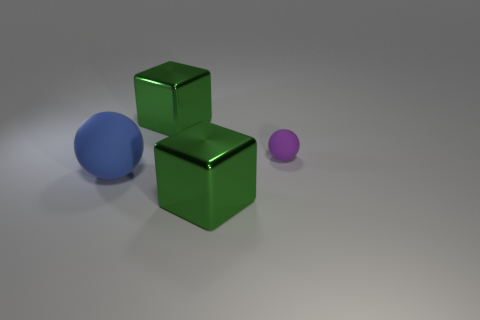Are there any other things that are the same size as the purple rubber sphere?
Keep it short and to the point. No. The rubber object that is behind the rubber ball in front of the purple rubber thing is what color?
Offer a terse response. Purple. How many spheres are blue rubber objects or large yellow things?
Ensure brevity in your answer.  1. How many large blue matte things are behind the cube that is in front of the blue rubber ball?
Offer a terse response. 1. The other object that is the same shape as the purple object is what size?
Keep it short and to the point. Large. What is the shape of the large green object in front of the large object behind the tiny purple object?
Offer a very short reply. Cube. The blue sphere has what size?
Offer a very short reply. Large. There is a blue thing; is its shape the same as the rubber object behind the blue thing?
Your answer should be very brief. Yes. Is the shape of the green object that is behind the purple sphere the same as  the tiny rubber object?
Give a very brief answer. No. How many metallic blocks are in front of the blue thing and behind the purple thing?
Provide a short and direct response. 0. 